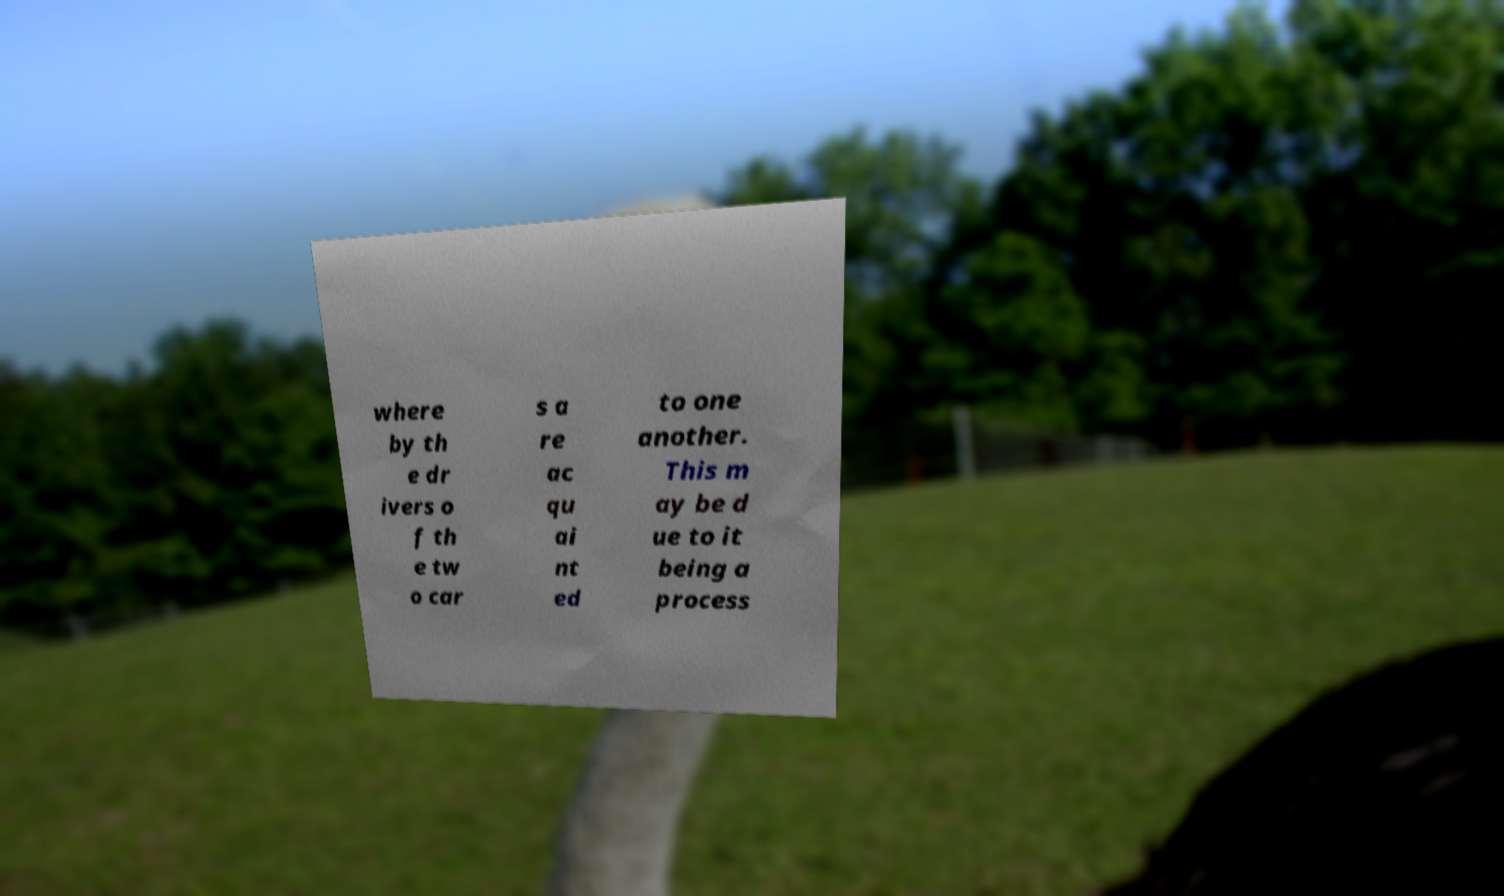Could you extract and type out the text from this image? where by th e dr ivers o f th e tw o car s a re ac qu ai nt ed to one another. This m ay be d ue to it being a process 